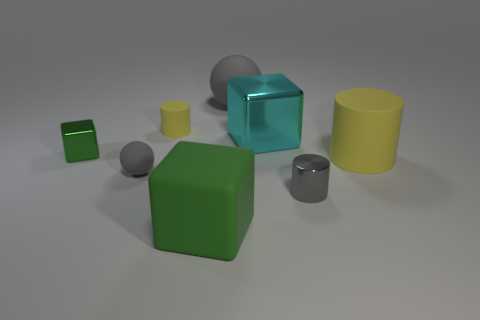Add 1 green blocks. How many objects exist? 9 Subtract all cubes. How many objects are left? 5 Add 6 blocks. How many blocks are left? 9 Add 2 large objects. How many large objects exist? 6 Subtract 0 purple blocks. How many objects are left? 8 Subtract all big cubes. Subtract all large gray rubber things. How many objects are left? 5 